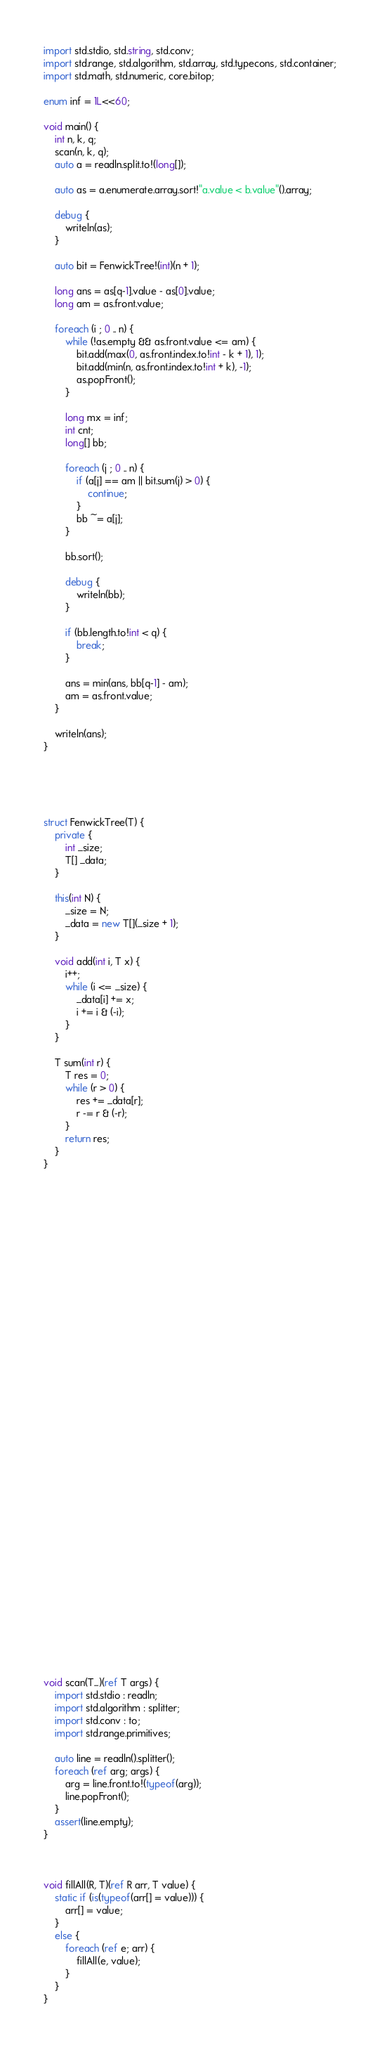Convert code to text. <code><loc_0><loc_0><loc_500><loc_500><_D_>import std.stdio, std.string, std.conv;
import std.range, std.algorithm, std.array, std.typecons, std.container;
import std.math, std.numeric, core.bitop;

enum inf = 1L<<60;

void main() {
    int n, k, q;
    scan(n, k, q);
    auto a = readln.split.to!(long[]);

    auto as = a.enumerate.array.sort!"a.value < b.value"().array;

    debug {
        writeln(as);
    }

    auto bit = FenwickTree!(int)(n + 1);

    long ans = as[q-1].value - as[0].value;
    long am = as.front.value;

    foreach (i ; 0 .. n) {
        while (!as.empty && as.front.value <= am) {
            bit.add(max(0, as.front.index.to!int - k + 1), 1);
            bit.add(min(n, as.front.index.to!int + k), -1);
            as.popFront();
        }

        long mx = inf;
        int cnt;
        long[] bb;

        foreach (j ; 0 .. n) {
            if (a[j] == am || bit.sum(j) > 0) {
                continue;
            }
            bb ~= a[j];
        }

        bb.sort();

        debug {
            writeln(bb);
        }

        if (bb.length.to!int < q) {
            break;
        }

        ans = min(ans, bb[q-1] - am);
        am = as.front.value;
    }

    writeln(ans);
}





struct FenwickTree(T) {
    private {
        int _size;
        T[] _data;
    }

    this(int N) {
        _size = N;
        _data = new T[](_size + 1);
    }

    void add(int i, T x) {
        i++;
        while (i <= _size) {
            _data[i] += x;
            i += i & (-i);
        }
    }

    T sum(int r) {
        T res = 0;
        while (r > 0) {
            res += _data[r];
            r -= r & (-r);
        }
        return res;
    }
}








































void scan(T...)(ref T args) {
    import std.stdio : readln;
    import std.algorithm : splitter;
    import std.conv : to;
    import std.range.primitives;

    auto line = readln().splitter();
    foreach (ref arg; args) {
        arg = line.front.to!(typeof(arg));
        line.popFront();
    }
    assert(line.empty);
}



void fillAll(R, T)(ref R arr, T value) {
    static if (is(typeof(arr[] = value))) {
        arr[] = value;
    }
    else {
        foreach (ref e; arr) {
            fillAll(e, value);
        }
    }
}
</code> 